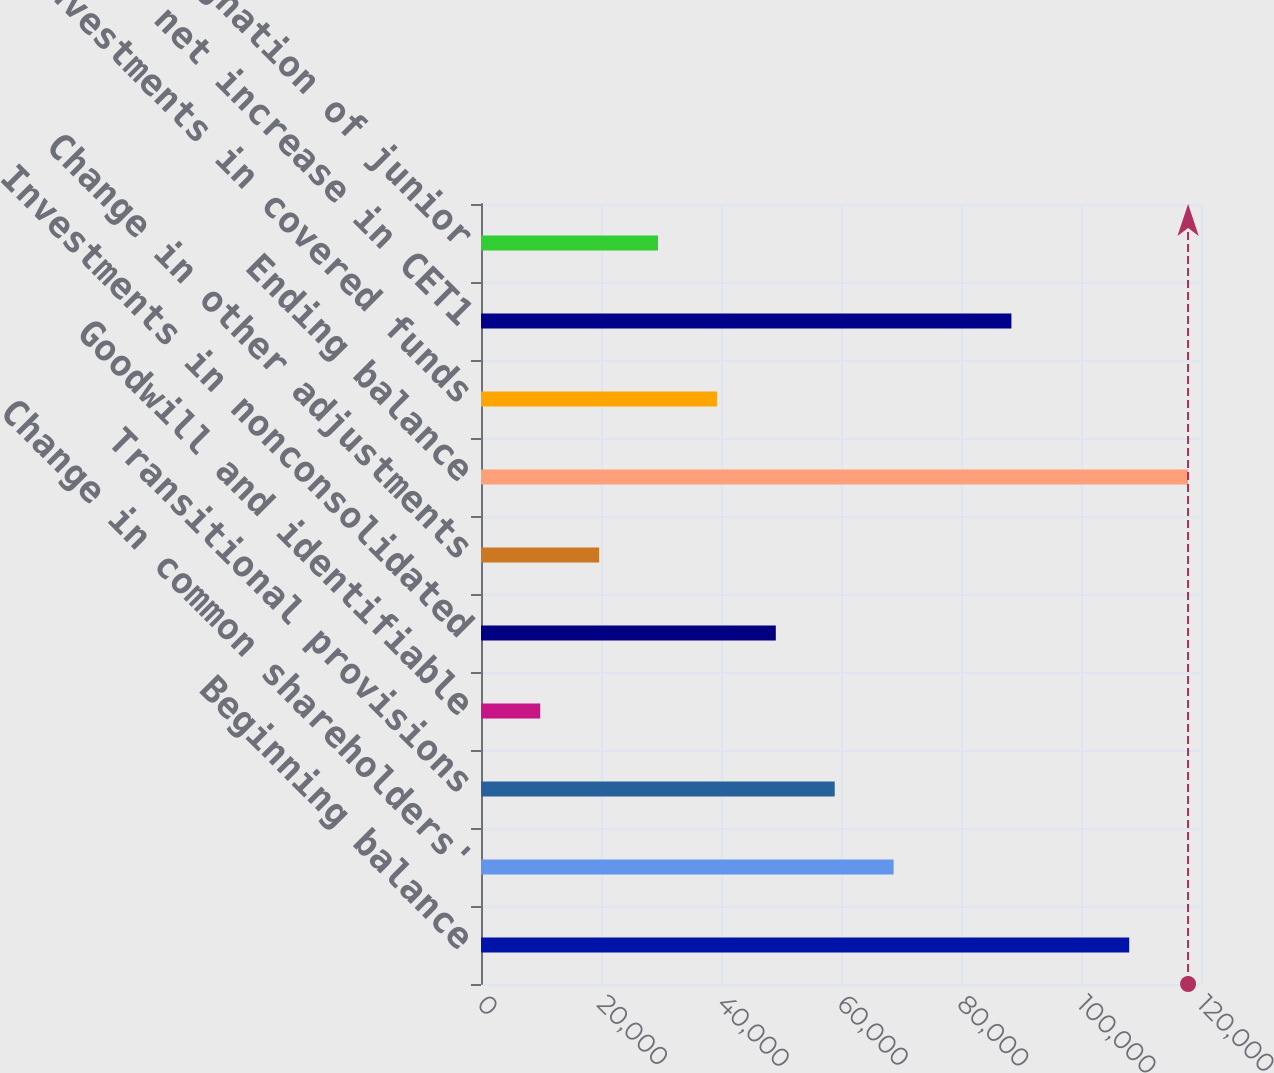Convert chart. <chart><loc_0><loc_0><loc_500><loc_500><bar_chart><fcel>Beginning balance<fcel>Change in common shareholders'<fcel>Transitional provisions<fcel>Goodwill and identifiable<fcel>Investments in nonconsolidated<fcel>Change in other adjustments<fcel>Ending balance<fcel>Investments in covered funds<fcel>Other net increase in CET1<fcel>Redesignation of junior<nl><fcel>108032<fcel>68767.1<fcel>58950.8<fcel>9869.3<fcel>49134.5<fcel>19685.6<fcel>117849<fcel>39318.2<fcel>88399.7<fcel>29501.9<nl></chart> 